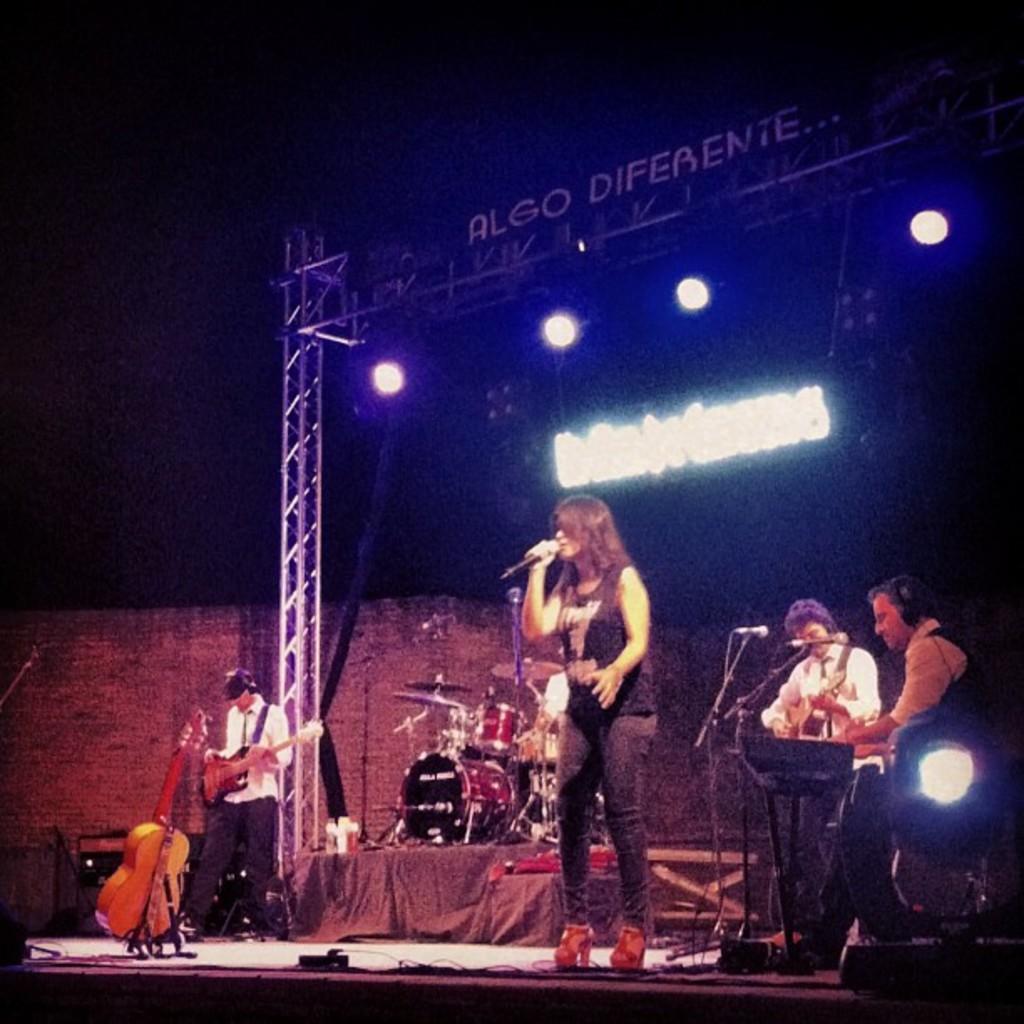Could you give a brief overview of what you see in this image? The picture is clicked in a musical concert. A black t shirt lady is singing with a mic in her hand. In the background there are people playing musical instruments. To the top of the roof there is written as "algo diferente", there are even white lights attached to the roof. There is a guitar to the left side of the image. 